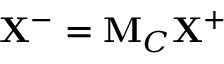Convert formula to latex. <formula><loc_0><loc_0><loc_500><loc_500>X ^ { - } = M _ { C } X ^ { + }</formula> 